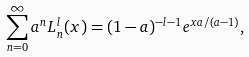Convert formula to latex. <formula><loc_0><loc_0><loc_500><loc_500>\sum _ { n = 0 } ^ { \infty } a ^ { n } L _ { n } ^ { l } ( x ) = ( 1 - a ) ^ { - l - 1 } e ^ { x a / ( a - 1 ) } ,</formula> 